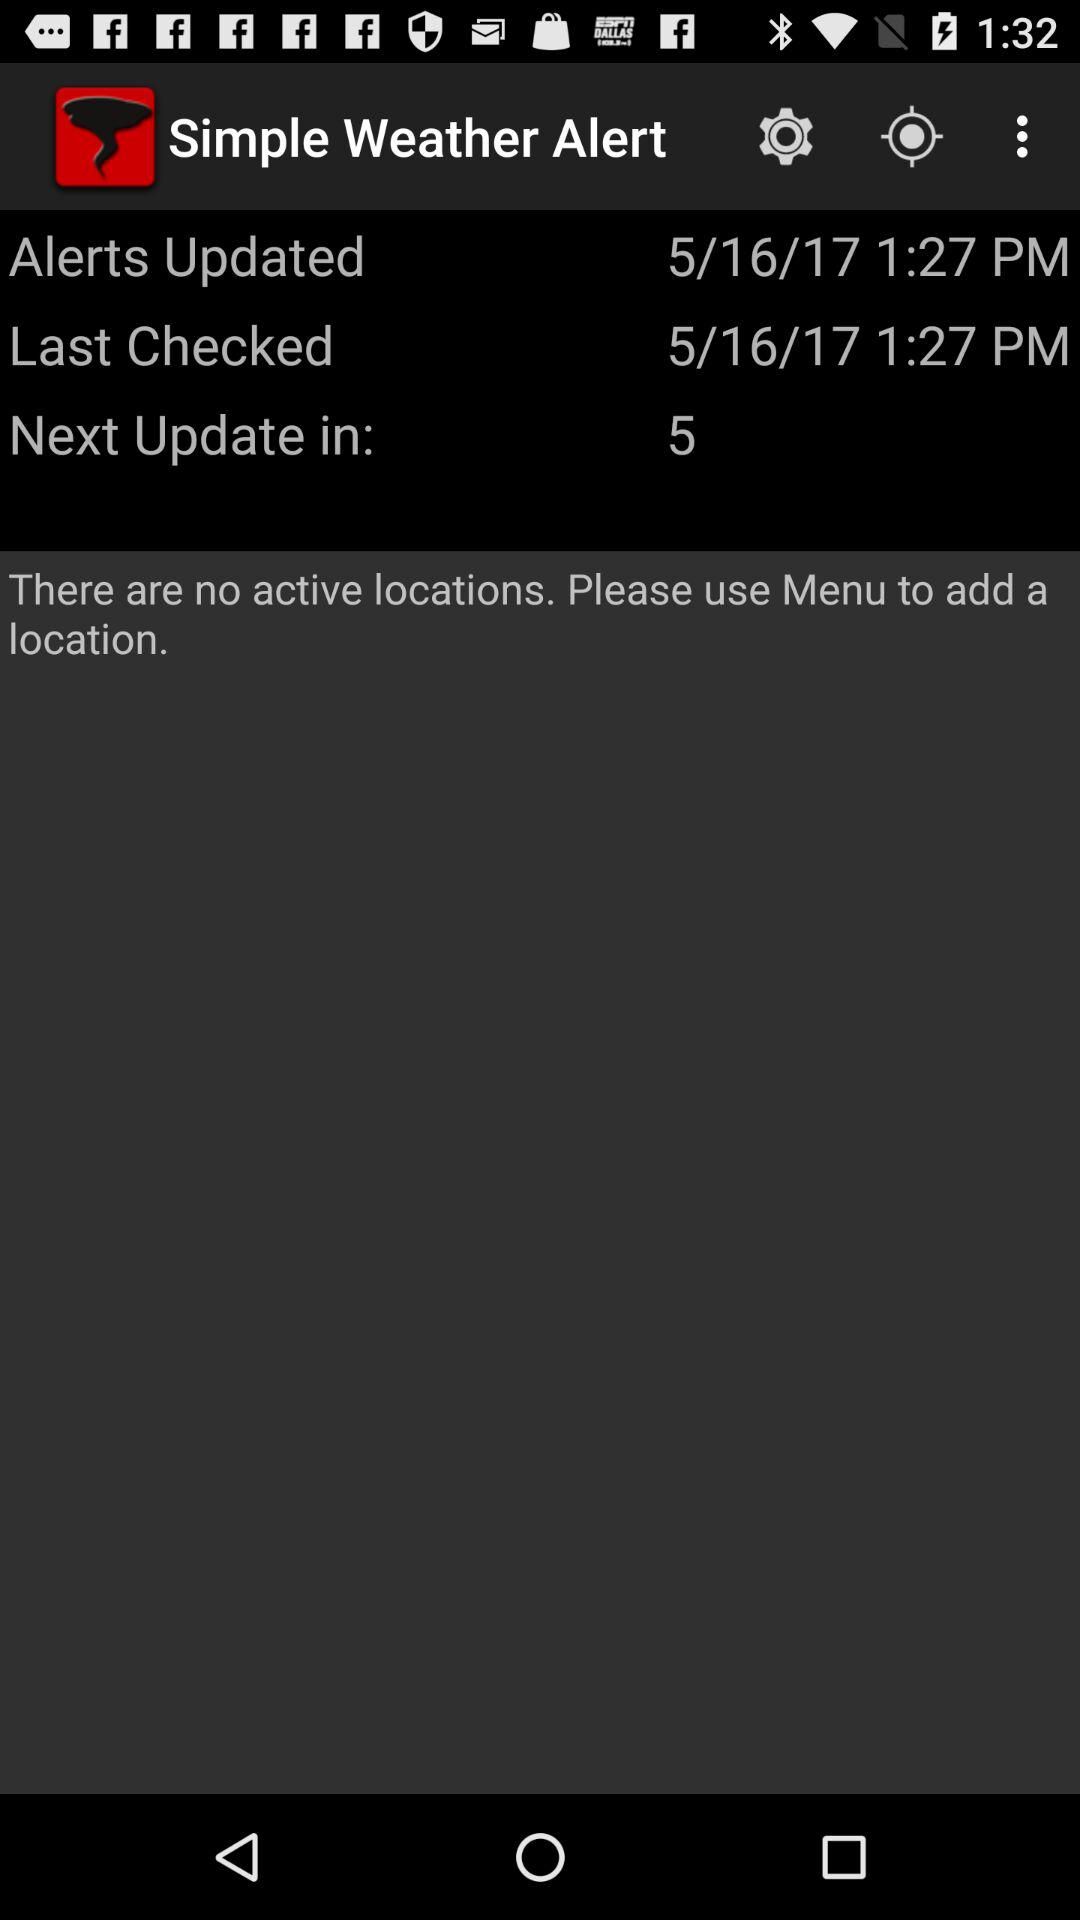On what date were the alerts updated? The alerts were updated on May 16, 2017. 